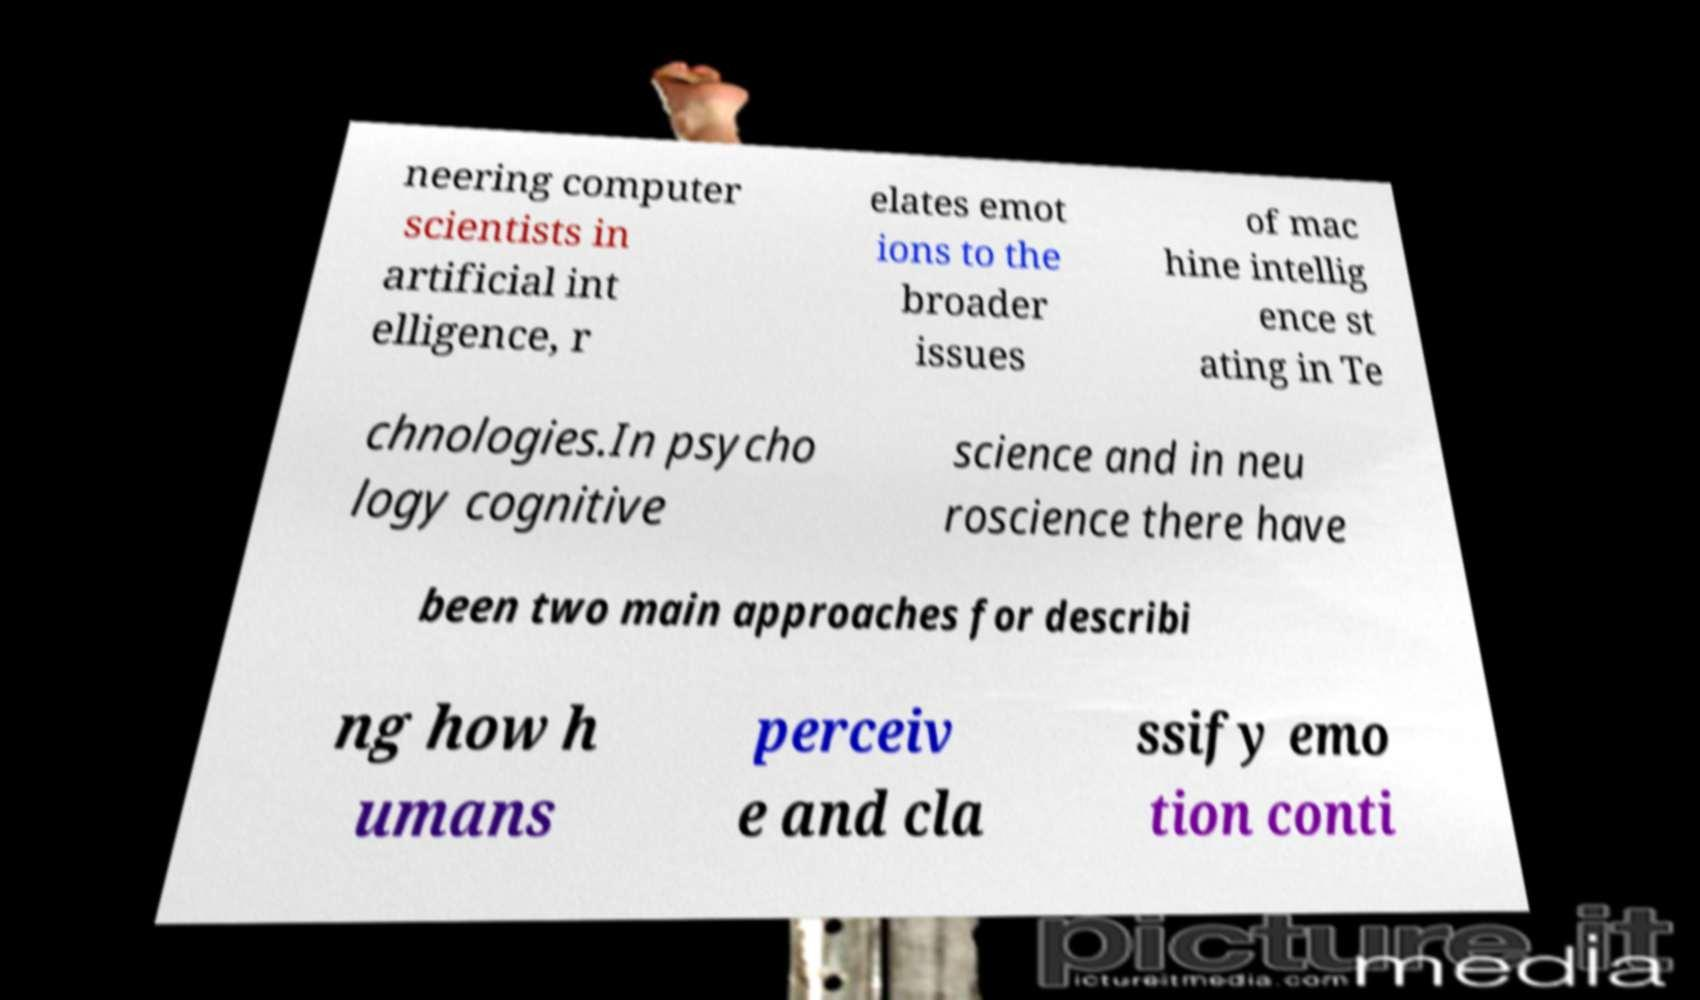Could you extract and type out the text from this image? neering computer scientists in artificial int elligence, r elates emot ions to the broader issues of mac hine intellig ence st ating in Te chnologies.In psycho logy cognitive science and in neu roscience there have been two main approaches for describi ng how h umans perceiv e and cla ssify emo tion conti 